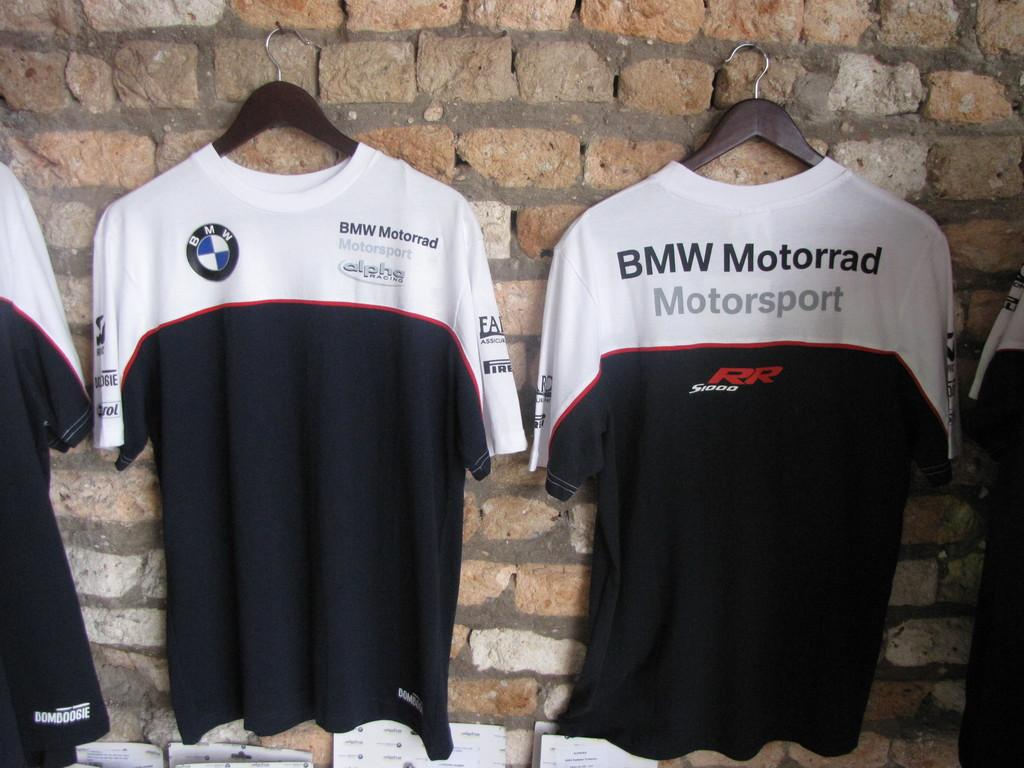<image>
Relay a brief, clear account of the picture shown. the tshirts are made for BMW Motorrad Motorsport 